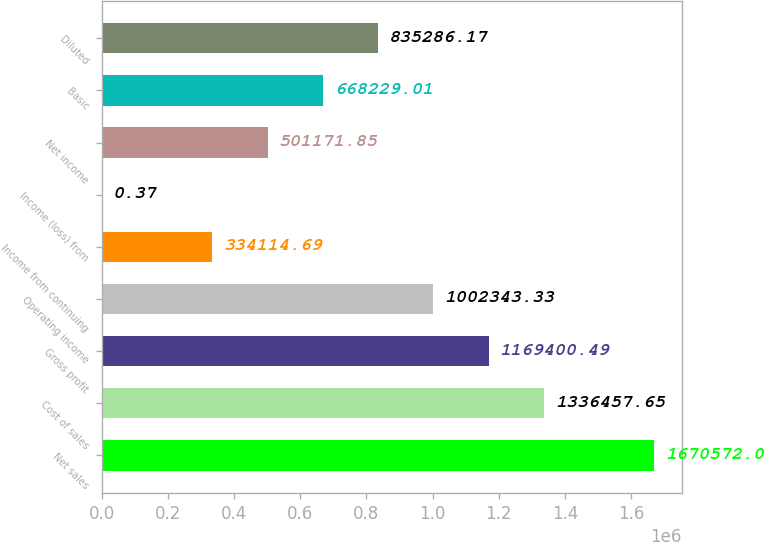<chart> <loc_0><loc_0><loc_500><loc_500><bar_chart><fcel>Net sales<fcel>Cost of sales<fcel>Gross profit<fcel>Operating income<fcel>Income from continuing<fcel>Income (loss) from<fcel>Net income<fcel>Basic<fcel>Diluted<nl><fcel>1.67057e+06<fcel>1.33646e+06<fcel>1.1694e+06<fcel>1.00234e+06<fcel>334115<fcel>0.37<fcel>501172<fcel>668229<fcel>835286<nl></chart> 